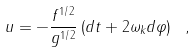<formula> <loc_0><loc_0><loc_500><loc_500>u = - \frac { f ^ { 1 / 2 } } { g ^ { 1 / 2 } } \left ( d t + 2 \omega _ { k } d \varphi \right ) \ ,</formula> 